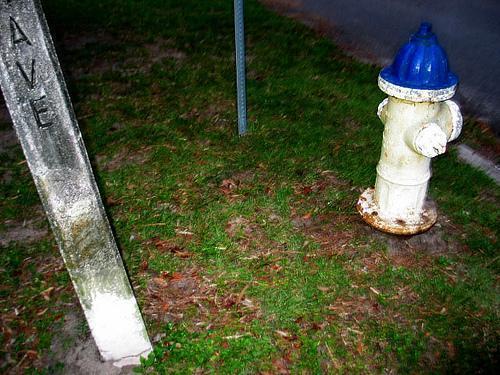How many fire hydrants by the street?
Give a very brief answer. 1. 